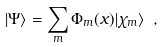<formula> <loc_0><loc_0><loc_500><loc_500>| \Psi \rangle = \sum _ { m } \Phi _ { m } ( x ) | \chi _ { m } \rangle \ ,</formula> 